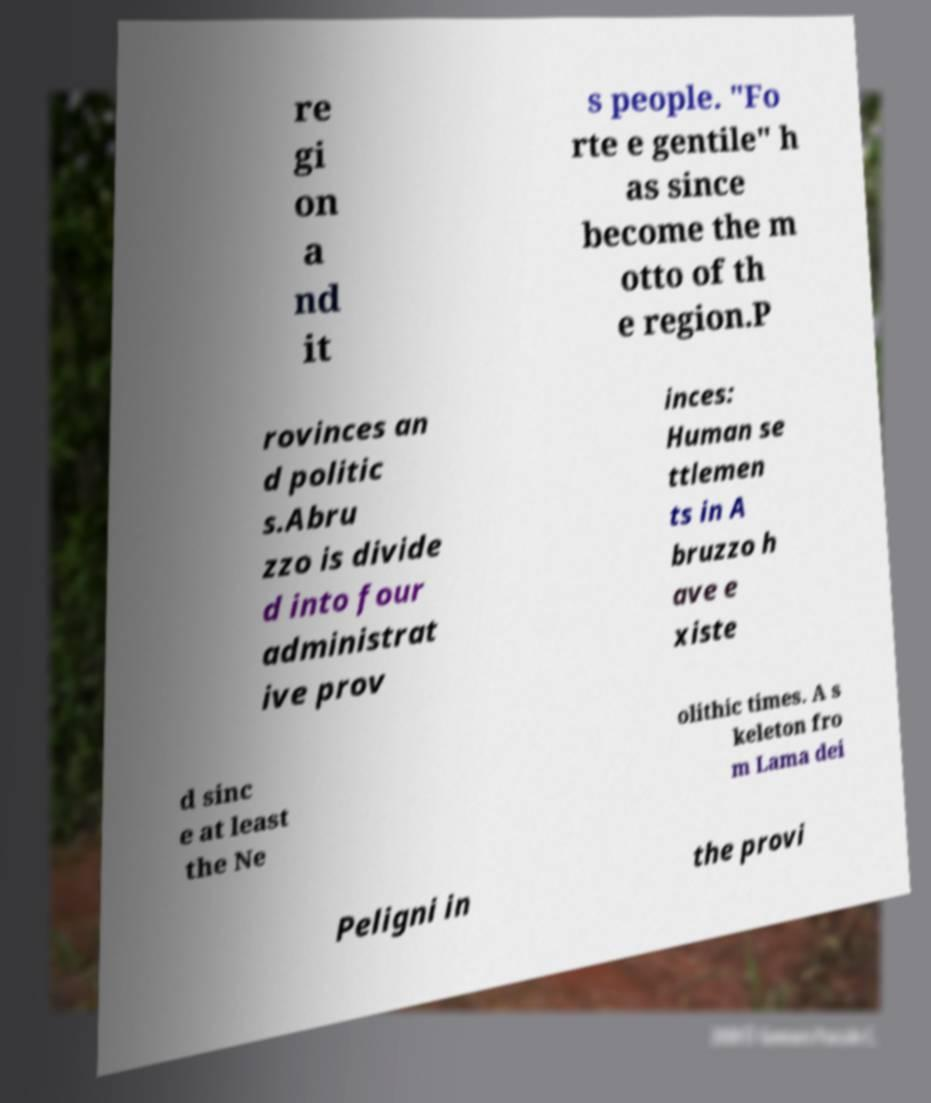I need the written content from this picture converted into text. Can you do that? re gi on a nd it s people. "Fo rte e gentile" h as since become the m otto of th e region.P rovinces an d politic s.Abru zzo is divide d into four administrat ive prov inces: Human se ttlemen ts in A bruzzo h ave e xiste d sinc e at least the Ne olithic times. A s keleton fro m Lama dei Peligni in the provi 